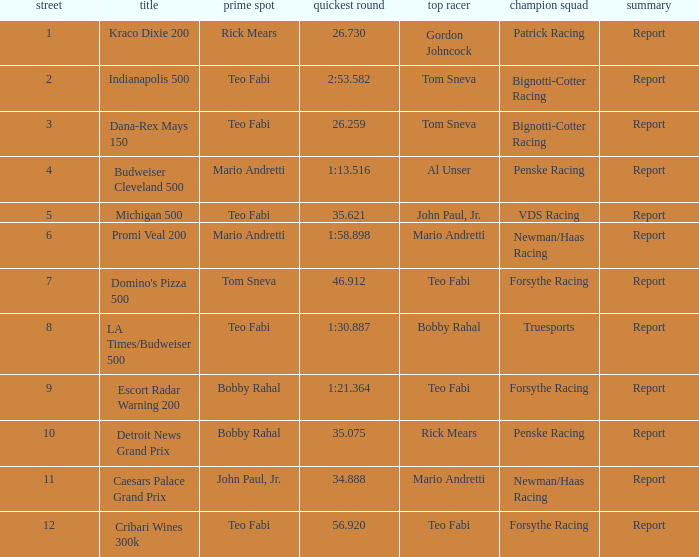How many winning drivers were there in the race that had a fastest lap time of 56.920? 1.0. 